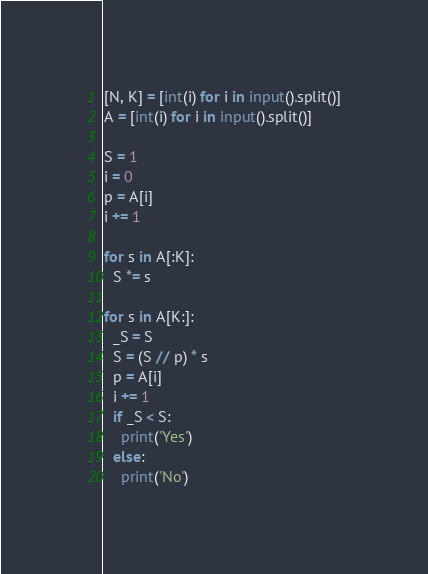Convert code to text. <code><loc_0><loc_0><loc_500><loc_500><_Python_>[N, K] = [int(i) for i in input().split()]
A = [int(i) for i in input().split()]

S = 1
i = 0
p = A[i]
i += 1

for s in A[:K]:
  S *= s 

for s in A[K:]:
  _S = S
  S = (S // p) * s
  p = A[i]
  i += 1
  if _S < S:
    print('Yes')
  else:
    print('No')</code> 